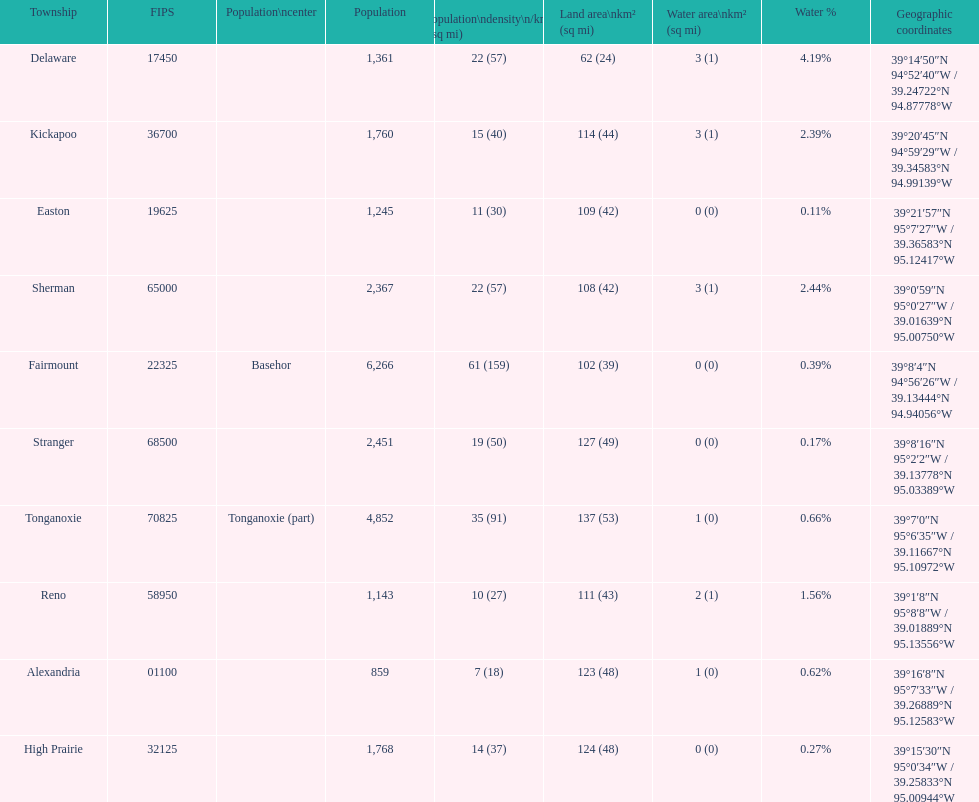Does alexandria county have a higher or lower population than delaware county? Lower. 